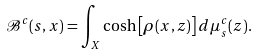Convert formula to latex. <formula><loc_0><loc_0><loc_500><loc_500>\mathcal { B } ^ { c } ( s , x ) = \int _ { X } \cosh \left [ \rho ( x , z ) \right ] d \mu _ { s } ^ { c } ( z ) .</formula> 